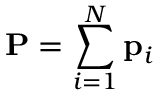Convert formula to latex. <formula><loc_0><loc_0><loc_500><loc_500>P = \sum _ { i = 1 } ^ { N } p _ { i }</formula> 